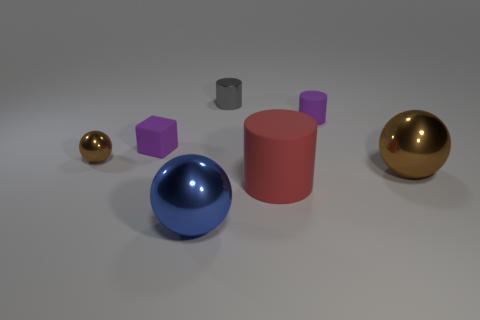What number of things are purple cubes or shiny spheres that are left of the tiny gray metal object?
Provide a succinct answer. 3. What is the material of the sphere behind the ball that is to the right of the tiny shiny thing that is behind the tiny brown metal ball?
Your answer should be very brief. Metal. The blue object that is the same material as the small gray cylinder is what size?
Offer a terse response. Large. There is a sphere that is behind the brown sphere to the right of the tiny gray thing; what is its color?
Make the answer very short. Brown. What number of things have the same material as the purple cylinder?
Provide a succinct answer. 2. How many shiny things are brown balls or small cubes?
Keep it short and to the point. 2. There is a brown ball that is the same size as the purple cylinder; what is it made of?
Keep it short and to the point. Metal. Is there a big blue sphere made of the same material as the gray thing?
Your answer should be very brief. Yes. There is a small metallic thing right of the brown metal object behind the big metal ball behind the large blue shiny thing; what is its shape?
Provide a short and direct response. Cylinder. There is a red cylinder; is its size the same as the rubber cylinder behind the red thing?
Your answer should be very brief. No. 